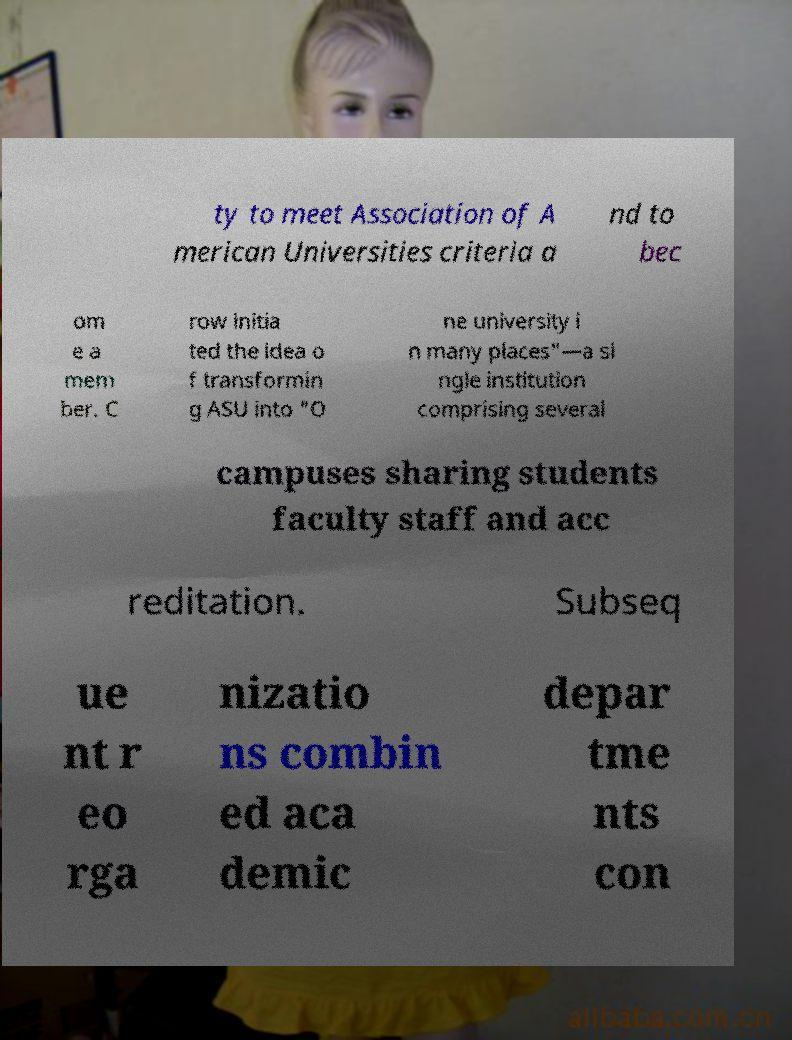Please read and relay the text visible in this image. What does it say? ty to meet Association of A merican Universities criteria a nd to bec om e a mem ber. C row initia ted the idea o f transformin g ASU into "O ne university i n many places"—a si ngle institution comprising several campuses sharing students faculty staff and acc reditation. Subseq ue nt r eo rga nizatio ns combin ed aca demic depar tme nts con 